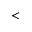<formula> <loc_0><loc_0><loc_500><loc_500><</formula> 